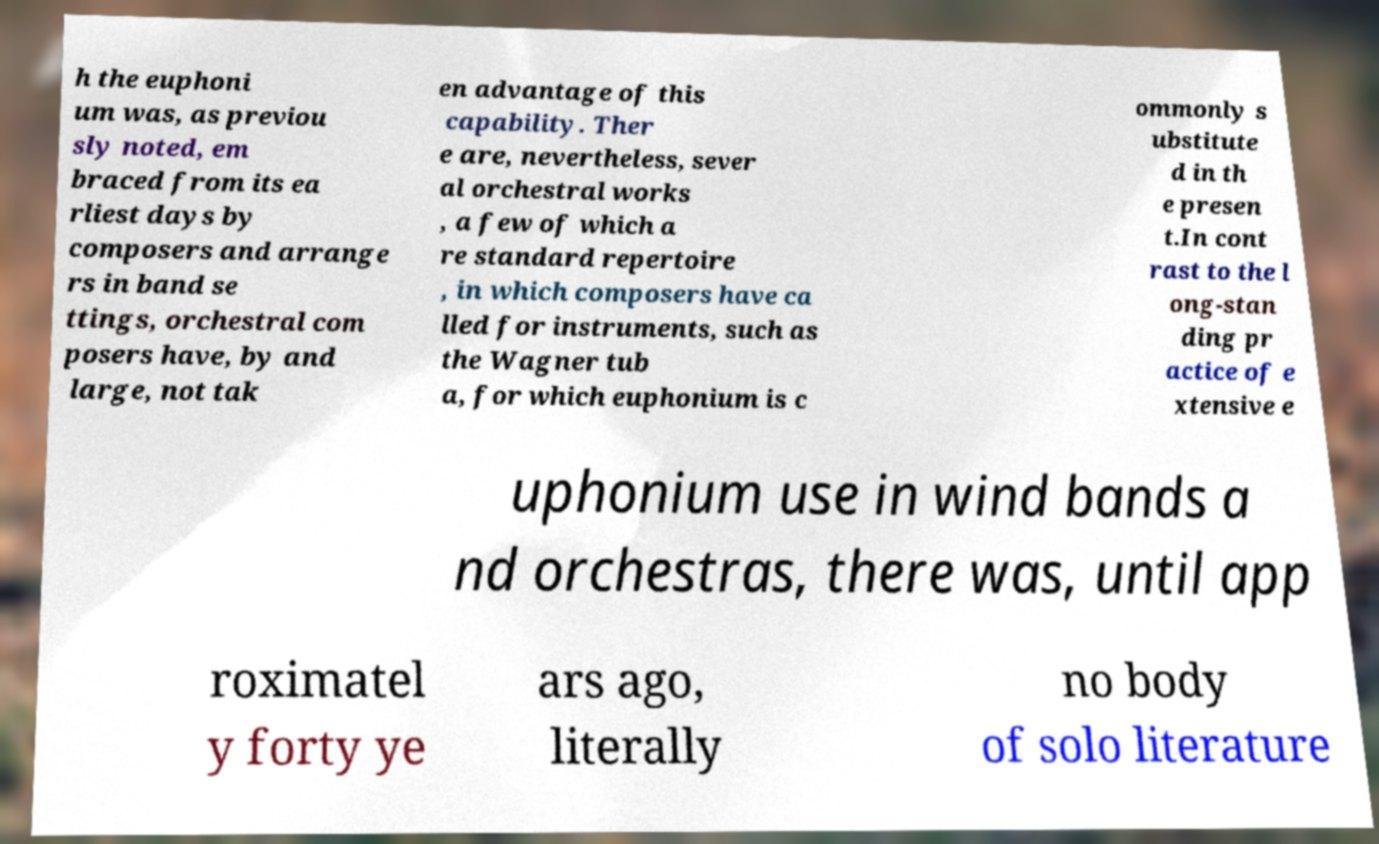What messages or text are displayed in this image? I need them in a readable, typed format. h the euphoni um was, as previou sly noted, em braced from its ea rliest days by composers and arrange rs in band se ttings, orchestral com posers have, by and large, not tak en advantage of this capability. Ther e are, nevertheless, sever al orchestral works , a few of which a re standard repertoire , in which composers have ca lled for instruments, such as the Wagner tub a, for which euphonium is c ommonly s ubstitute d in th e presen t.In cont rast to the l ong-stan ding pr actice of e xtensive e uphonium use in wind bands a nd orchestras, there was, until app roximatel y forty ye ars ago, literally no body of solo literature 